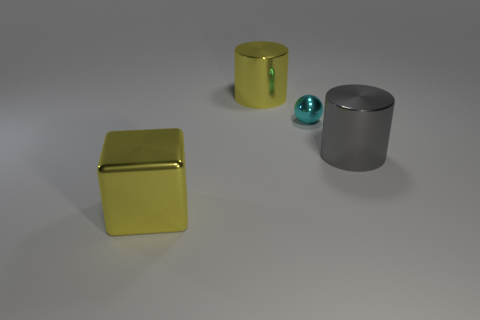Are there more big gray things than yellow objects?
Your response must be concise. No. What size is the metal cylinder that is the same color as the big metal block?
Your answer should be compact. Large. Is there another cylinder made of the same material as the large yellow cylinder?
Your answer should be very brief. Yes. The large metal thing that is in front of the cyan object and on the left side of the cyan metal object has what shape?
Your answer should be compact. Cube. How many other things are the same shape as the tiny shiny thing?
Keep it short and to the point. 0. What size is the gray metallic cylinder?
Your response must be concise. Large. How many things are big metallic cubes or gray things?
Offer a terse response. 2. There is a metal cylinder on the right side of the tiny sphere; what is its size?
Your answer should be compact. Large. Is there anything else that has the same size as the metallic sphere?
Give a very brief answer. No. There is a object that is both in front of the sphere and to the left of the gray metal cylinder; what color is it?
Offer a very short reply. Yellow. 